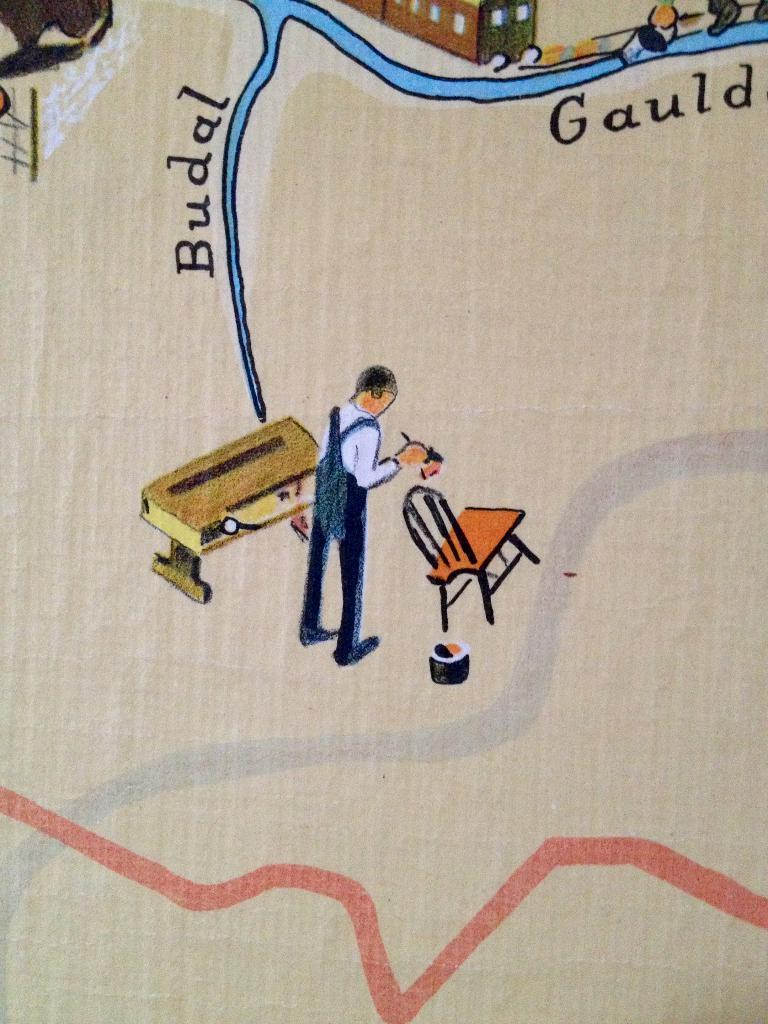What material is the image printed on? The image appears to be on a cardboard. What objects are depicted in the paintings within the image? There are paintings of a table, a man, a chair, water, railing, and a building in the image. Is there any text present in the image? Yes, there is text present in the image. Can you see the tail of the animal in the image? There is no animal present in the image, and therefore no tail can be seen. How many toes are visible on the person in the image? There is no person visible in the image, only paintings of various objects and scenes. 